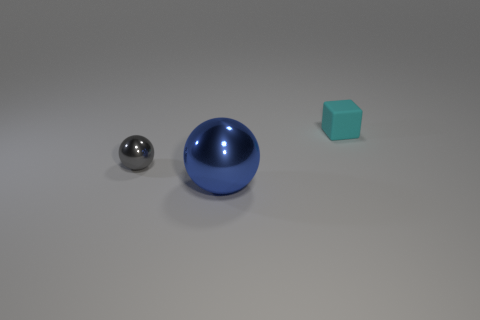Is there anything else that has the same material as the cyan block?
Make the answer very short. No. Is there any other thing that is the same size as the blue sphere?
Provide a succinct answer. No. Are there fewer spheres that are on the right side of the matte thing than tiny matte objects that are on the right side of the small gray ball?
Provide a short and direct response. Yes. How many things are either tiny red shiny things or objects that are in front of the small matte cube?
Your answer should be very brief. 2. What material is the cyan cube that is the same size as the gray metallic object?
Give a very brief answer. Rubber. Do the gray sphere and the blue thing have the same material?
Your answer should be very brief. Yes. The object that is behind the big metallic thing and to the left of the cyan matte thing is what color?
Your answer should be very brief. Gray. Does the tiny object left of the cyan object have the same color as the big metallic thing?
Keep it short and to the point. No. The cyan object that is the same size as the gray ball is what shape?
Your answer should be very brief. Cube. How many other things are there of the same material as the big blue thing?
Provide a short and direct response. 1. 